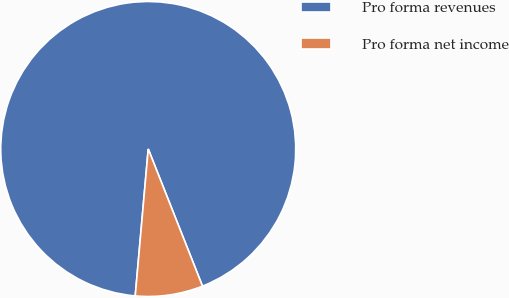<chart> <loc_0><loc_0><loc_500><loc_500><pie_chart><fcel>Pro forma revenues<fcel>Pro forma net income<nl><fcel>92.6%<fcel>7.4%<nl></chart> 